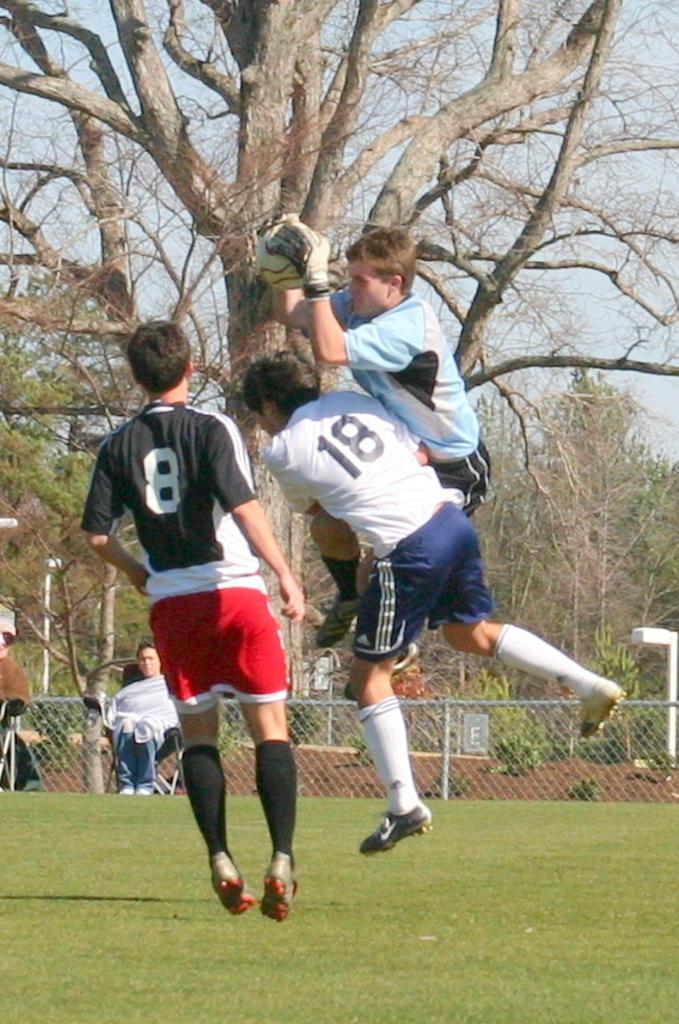Can you describe this image briefly? In this image I can see three persons in the air. In front the person is wearing black, white and red color dress. In the background I can see the railing, few trees in green color and the sky is in white and blue color. 